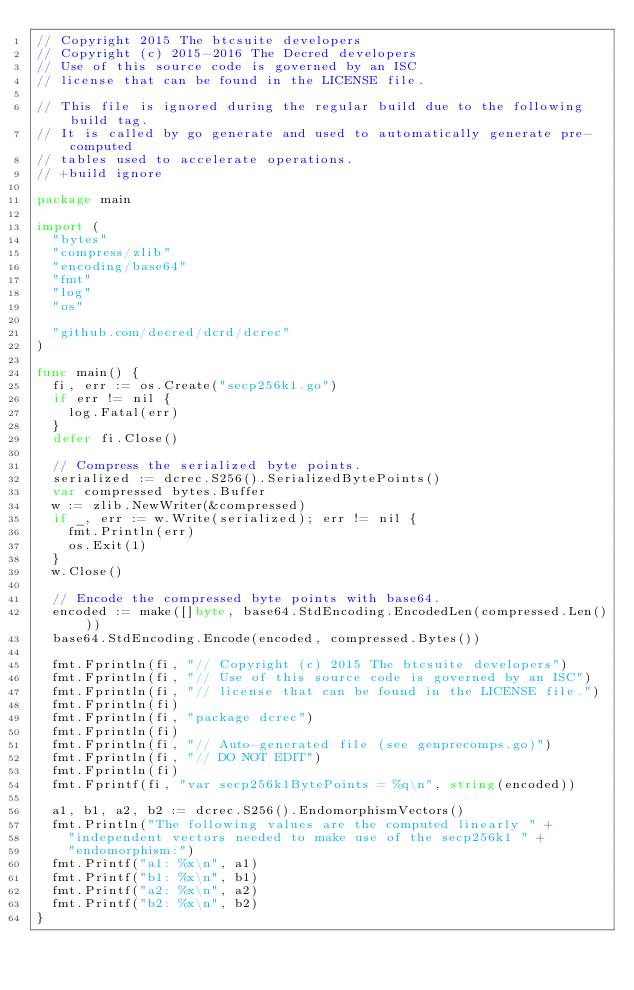Convert code to text. <code><loc_0><loc_0><loc_500><loc_500><_Go_>// Copyright 2015 The btcsuite developers
// Copyright (c) 2015-2016 The Decred developers
// Use of this source code is governed by an ISC
// license that can be found in the LICENSE file.

// This file is ignored during the regular build due to the following build tag.
// It is called by go generate and used to automatically generate pre-computed
// tables used to accelerate operations.
// +build ignore

package main

import (
	"bytes"
	"compress/zlib"
	"encoding/base64"
	"fmt"
	"log"
	"os"

	"github.com/decred/dcrd/dcrec"
)

func main() {
	fi, err := os.Create("secp256k1.go")
	if err != nil {
		log.Fatal(err)
	}
	defer fi.Close()

	// Compress the serialized byte points.
	serialized := dcrec.S256().SerializedBytePoints()
	var compressed bytes.Buffer
	w := zlib.NewWriter(&compressed)
	if _, err := w.Write(serialized); err != nil {
		fmt.Println(err)
		os.Exit(1)
	}
	w.Close()

	// Encode the compressed byte points with base64.
	encoded := make([]byte, base64.StdEncoding.EncodedLen(compressed.Len()))
	base64.StdEncoding.Encode(encoded, compressed.Bytes())

	fmt.Fprintln(fi, "// Copyright (c) 2015 The btcsuite developers")
	fmt.Fprintln(fi, "// Use of this source code is governed by an ISC")
	fmt.Fprintln(fi, "// license that can be found in the LICENSE file.")
	fmt.Fprintln(fi)
	fmt.Fprintln(fi, "package dcrec")
	fmt.Fprintln(fi)
	fmt.Fprintln(fi, "// Auto-generated file (see genprecomps.go)")
	fmt.Fprintln(fi, "// DO NOT EDIT")
	fmt.Fprintln(fi)
	fmt.Fprintf(fi, "var secp256k1BytePoints = %q\n", string(encoded))

	a1, b1, a2, b2 := dcrec.S256().EndomorphismVectors()
	fmt.Println("The following values are the computed linearly " +
		"independent vectors needed to make use of the secp256k1 " +
		"endomorphism:")
	fmt.Printf("a1: %x\n", a1)
	fmt.Printf("b1: %x\n", b1)
	fmt.Printf("a2: %x\n", a2)
	fmt.Printf("b2: %x\n", b2)
}
</code> 